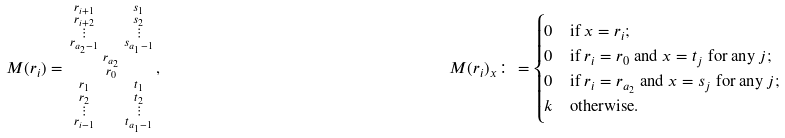Convert formula to latex. <formula><loc_0><loc_0><loc_500><loc_500>& M ( r _ { i } ) = \begin{smallmatrix} r _ { i + 1 } & & s _ { 1 } \\ r _ { i + 2 } & & s _ { 2 } \\ \vdots & & \vdots \\ r _ { a _ { 2 } - 1 } & & s _ { a _ { 1 } - 1 } \\ & r _ { a _ { 2 } } & \\ & r _ { 0 } & \\ r _ { 1 } & & t _ { 1 } \\ r _ { 2 } & & t _ { 2 } \\ \vdots & & \vdots \\ r _ { i - 1 } & & t _ { a _ { 1 } - 1 } \end{smallmatrix} , \quad & M ( r _ { i } ) _ { x } \colon = \begin{cases} 0 & \text {if $x=r_{i}$;} \\ 0 & \text {if $r_{i}=r_{0}$ and $x=t_{j}$ for any $j$;} \\ 0 & \text {if $r_{i}=r_{a_{2}}$ and $x=s_{j}$ for any $j$;} \\ k & \text {otherwise.} \end{cases}</formula> 